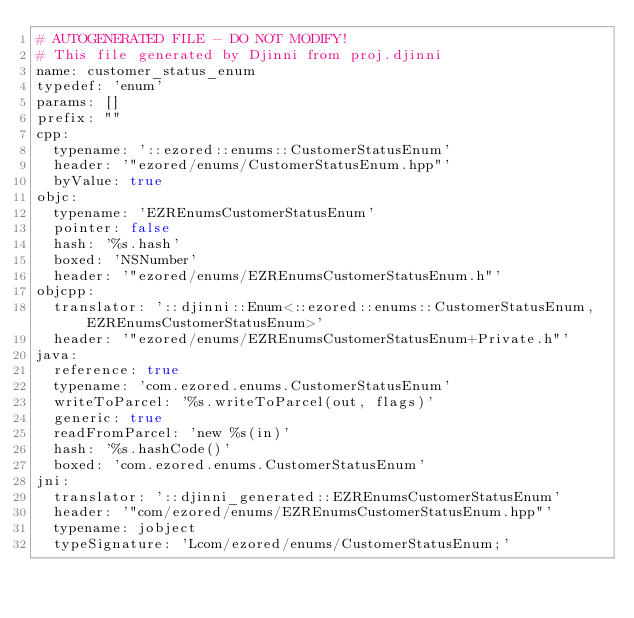<code> <loc_0><loc_0><loc_500><loc_500><_YAML_># AUTOGENERATED FILE - DO NOT MODIFY!
# This file generated by Djinni from proj.djinni
name: customer_status_enum
typedef: 'enum'
params: []
prefix: ""
cpp:
  typename: '::ezored::enums::CustomerStatusEnum'
  header: '"ezored/enums/CustomerStatusEnum.hpp"'
  byValue: true
objc:
  typename: 'EZREnumsCustomerStatusEnum'
  pointer: false
  hash: '%s.hash'
  boxed: 'NSNumber'
  header: '"ezored/enums/EZREnumsCustomerStatusEnum.h"'
objcpp:
  translator: '::djinni::Enum<::ezored::enums::CustomerStatusEnum, EZREnumsCustomerStatusEnum>'
  header: '"ezored/enums/EZREnumsCustomerStatusEnum+Private.h"'
java:
  reference: true
  typename: 'com.ezored.enums.CustomerStatusEnum'
  writeToParcel: '%s.writeToParcel(out, flags)'
  generic: true
  readFromParcel: 'new %s(in)'
  hash: '%s.hashCode()'
  boxed: 'com.ezored.enums.CustomerStatusEnum'
jni:
  translator: '::djinni_generated::EZREnumsCustomerStatusEnum'
  header: '"com/ezored/enums/EZREnumsCustomerStatusEnum.hpp"'
  typename: jobject
  typeSignature: 'Lcom/ezored/enums/CustomerStatusEnum;'
</code> 